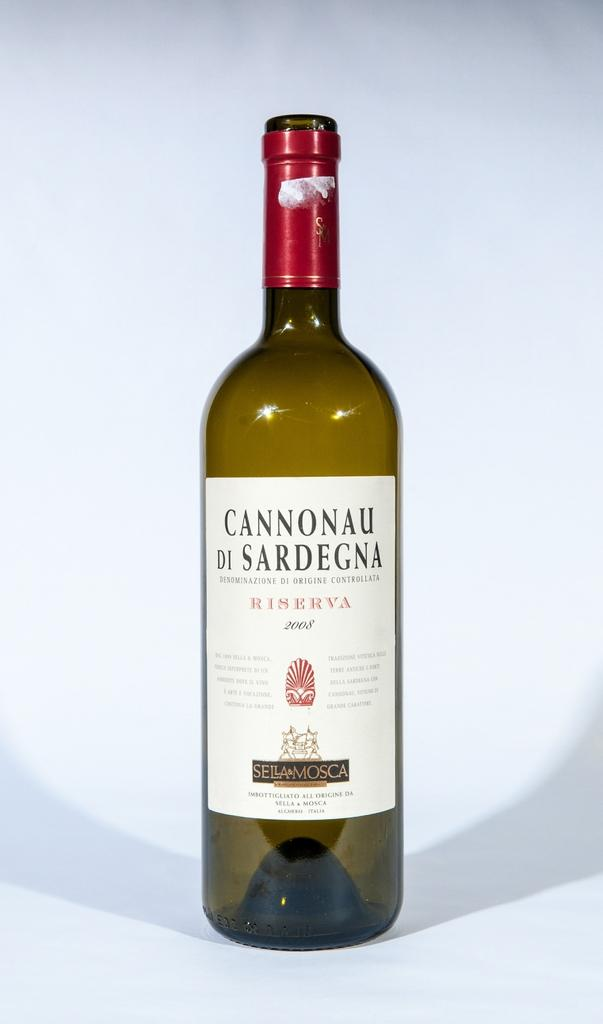<image>
Present a compact description of the photo's key features. A round big bottle of Cannonau di Sardegna by Sella & Mosca 